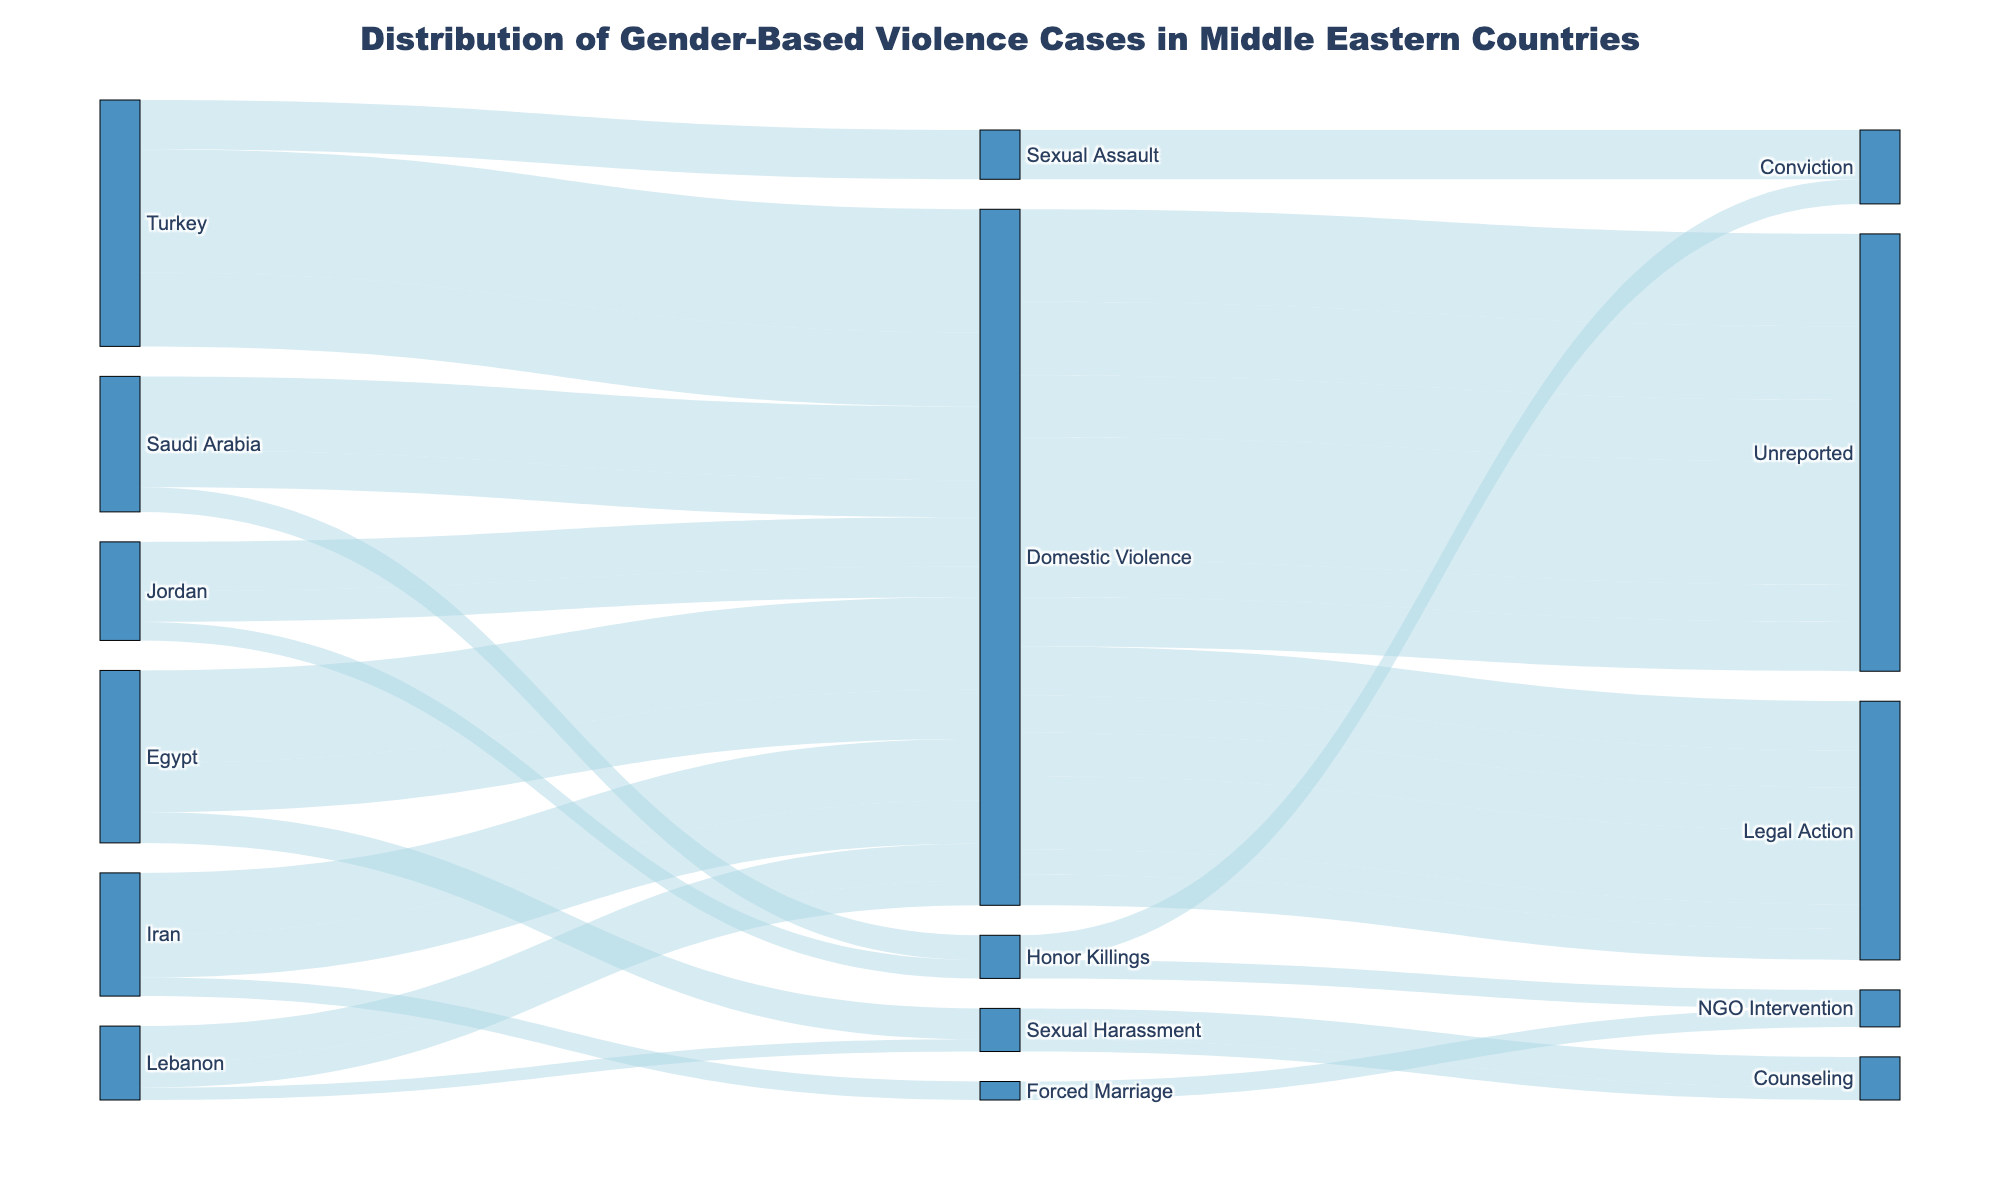What is the title of the figure? The title of the figure is located at the top and provides a brief description of the chart's content. The title reads "Distribution of Gender-Based Violence Cases in Middle Eastern Countries."
Answer: Distribution of Gender-Based Violence Cases in Middle Eastern Countries Which country reports the highest number of domestic violence cases? Look at the source nodes associated with Domestic Violence and compare the values from each country. Turkey reports 3200 cases (2000 unreported + 1200 legal action), the highest among the listed countries.
Answer: Turkey What is the total number of unreported domestic violence cases across all listed countries? Sum the unreported domestic violence cases from each country: Egypt (1500), Saudi Arabia (1200), Iran (1000), Turkey (2000), Lebanon (600), and Jordan (800). The total is 1500 + 1200 + 1000 + 2000 + 600 + 800 = 7100.
Answer: 7100 How many reported cases of sexual harassment in Egypt resulted in counseling? Look specifically at the node linking Sexual Harassment to Counseling for Egypt. The chart shows 500 cases.
Answer: 500 Which outcome has the highest number of reported cases of domestic violence in Turkey? Compare the values for outcomes of domestic violence in Turkey: 2000 unreported and 1200 legal action. Unreported has the highest number.
Answer: Unreported How does the number of domestic violence cases resulting in legal action compare between Saudi Arabia and Iran? Look at the nodes for Domestic Violence cases resulting in Legal Action for Saudi Arabia (600) and Iran (700). Iran has more cases.
Answer: Iran What percentage of honor killing cases in Saudi Arabia resulted in conviction? Sum the total honor killing cases in Saudi Arabia (400). As there’s only one outcome type (conviction) for honor killings in Saudi Arabia, this translates to 100%.
Answer: 100% What are the possible outcomes for forced marriage cases in Iran, and how many cases led to each outcome? Identify the node for Iran's forced marriage cases linked to outcomes. There’s only one path: NGO Intervention with 300 cases.
Answer: NGO Intervention: 300 Are there more reported cases of sexual harassment or sexual assault in the provided regions? Compare the total cases of sexual harassment (Egypt: 500, Lebanon: 200) and sexual assault (Turkey: 800). 500 + 200 = 700 for sexual harassment, and 800 for sexual assault. Sexual assault has more cases.
Answer: Sexual Assault 